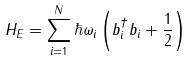<formula> <loc_0><loc_0><loc_500><loc_500>H _ { E } = \sum _ { i = 1 } ^ { N } \hbar { \omega } _ { i } \left ( b _ { i } ^ { \dagger } b _ { i } + \frac { 1 } { 2 } \right )</formula> 